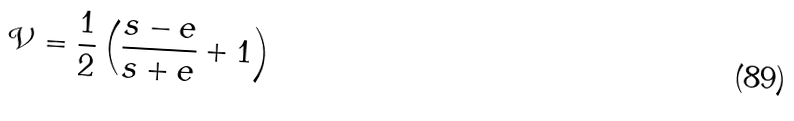<formula> <loc_0><loc_0><loc_500><loc_500>\mathcal { V } = \frac { 1 } { 2 } \left ( \frac { s - e } { s + e } + 1 \right )</formula> 